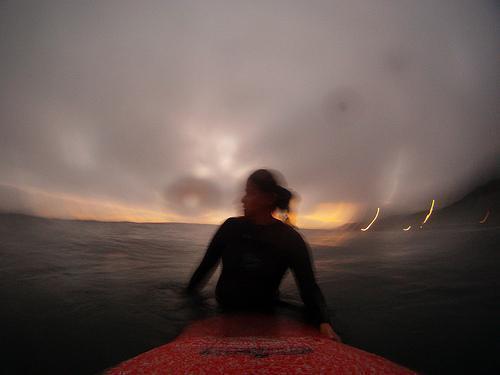How many people?
Give a very brief answer. 1. How many surfers are in the photo?
Give a very brief answer. 1. 